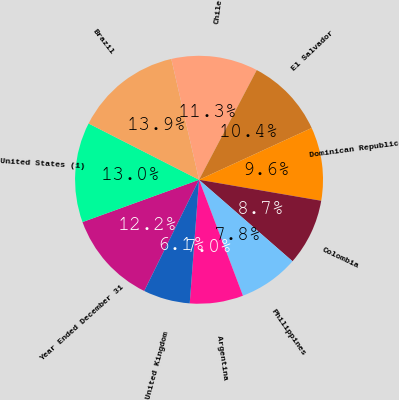<chart> <loc_0><loc_0><loc_500><loc_500><pie_chart><fcel>Year Ended December 31<fcel>United States (1)<fcel>Brazil<fcel>Chile<fcel>El Salvador<fcel>Dominican Republic<fcel>Colombia<fcel>Philippines<fcel>Argentina<fcel>United Kingdom<nl><fcel>12.17%<fcel>13.04%<fcel>13.91%<fcel>11.3%<fcel>10.43%<fcel>9.57%<fcel>8.7%<fcel>7.83%<fcel>6.96%<fcel>6.09%<nl></chart> 